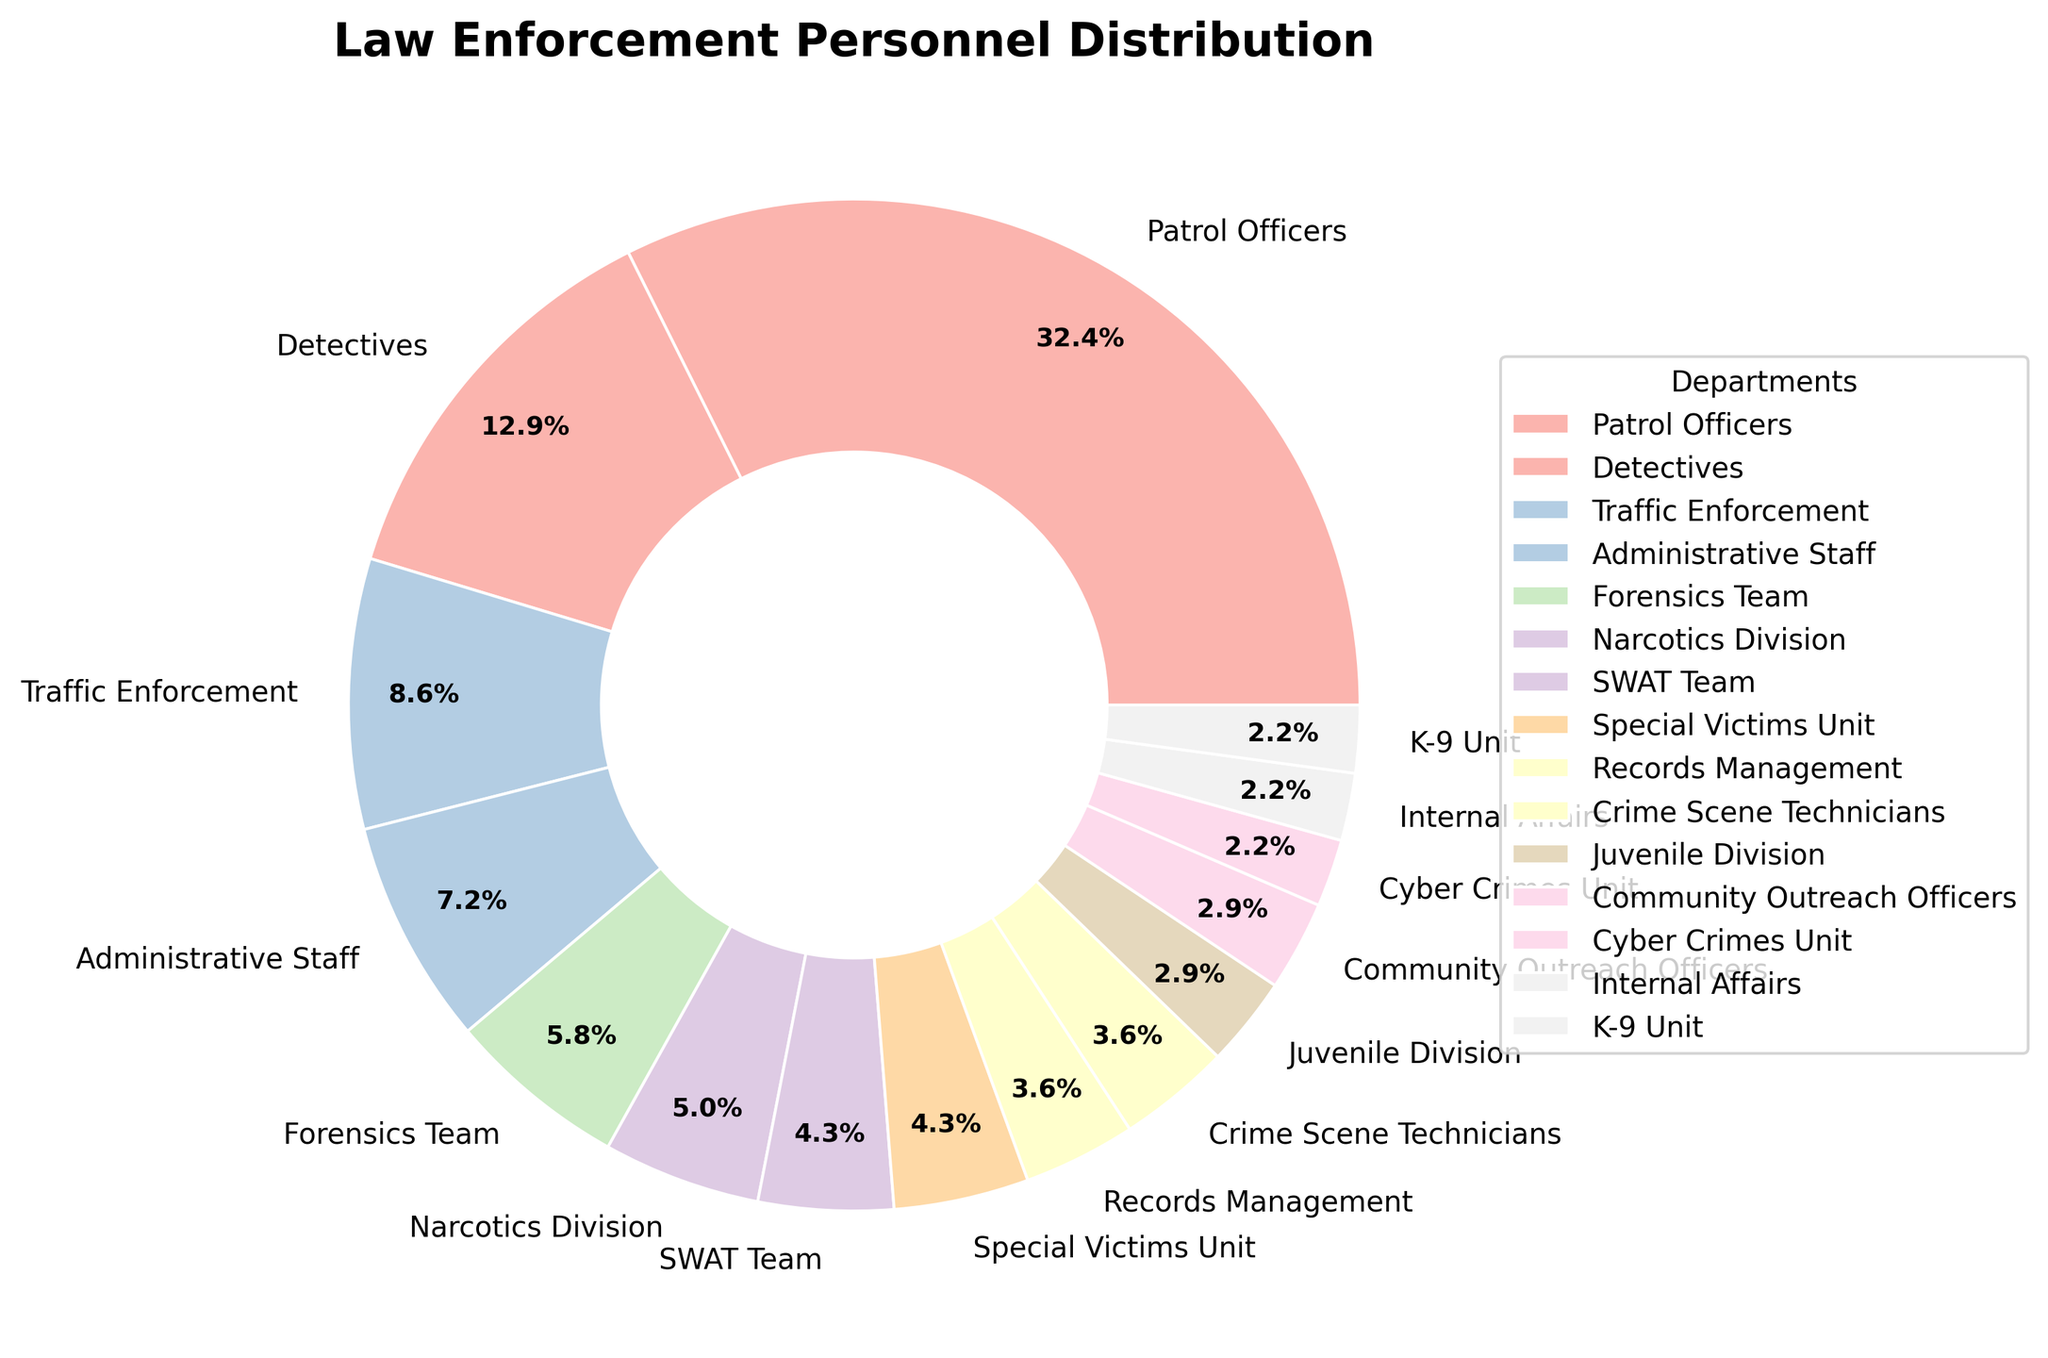Which department has the highest percentage of personnel? The Patrol Officers section in the pie chart appears to occupy the largest slice. By inspecting the labels given to each pie section, the Patrol Officers have the highest percentage.
Answer: Patrol Officers What is the combined percentage of the Special Victims Unit, Narcotics Division, and SWAT Team? We need to sum the percentages for the Special Victims Unit (which is marked as 6%), the Narcotics Division (7%), and the SWAT Team (6%). By adding 6%, 7%, and 6%, we get a combined percentage.
Answer: 19% Which two departments have the smallest number of personnel? By looking at the smallest slices in the pie chart and checking their corresponding labels, the K-9 Unit and Cyber Crimes Unit appear to be the smallest. Confirming this with their personnel counts of 3 each.
Answer: K-9 Unit and Cyber Crimes Unit How does the number of Forensics Team personnel compare to that of Traffic Enforcement? Comparing the sizes of their respective pie chart sections, Traffic Enforcement's section is slightly larger. Traffic Enforcement has 12 personnel, while Forensics Team has 8.
Answer: Traffic Enforcement has more personnel Calculate the total percentage for departments with exactly 3 personnel. We look for sections with 3 personnel (K-9 Unit, Internal Affairs, and Cyber Crimes Unit). Each of these departments has 3 personnel, so we sum their percentages labeled as follows: K-9 Unit (3%), Internal Affairs (3%), Cyber Crimes Unit (3%). Adding these together gives the total percentage.
Answer: 9% What is the difference in percentage between Patrol Officers and Detectives? From the chart, we recognize that the Patrol Officers have the largest percentage and the Detectives have the next substantial section. By subtracting the Detectives' percentage from that of the Patrol Officers (45% - 18%), we get the difference.
Answer: 27% Which department section has a color closest to the first wedge in the chart? The first wedge being the Patrol Officers, which is labeled with a color typically associated with the start of the palette (e.g., a light pastel color). We visually observe the colors to find the closest. Forensic Team's section is near this color palette.
Answer: Forensic Team 